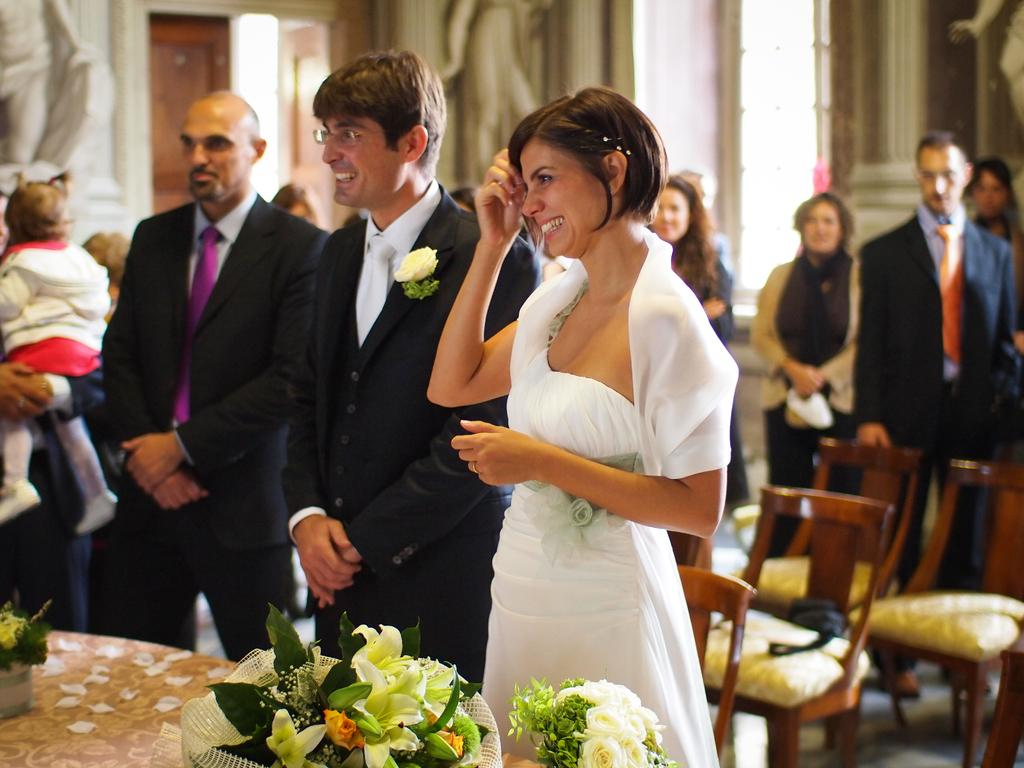What are the people in the image doing? The people in the image are standing. Can you describe the woman in the image? The woman is holding a baby in the image. What can be seen on the table in the image? There are flower bouquets on a table in the image. What type of furniture is present in the image? There are chairs in the image. What is the statue in the image made of? The statue in the image is made of a material that is not mentioned in the facts. What type of honey is being collected by the people in the image? There is no mention of honey or any activity related to honey in the image. 